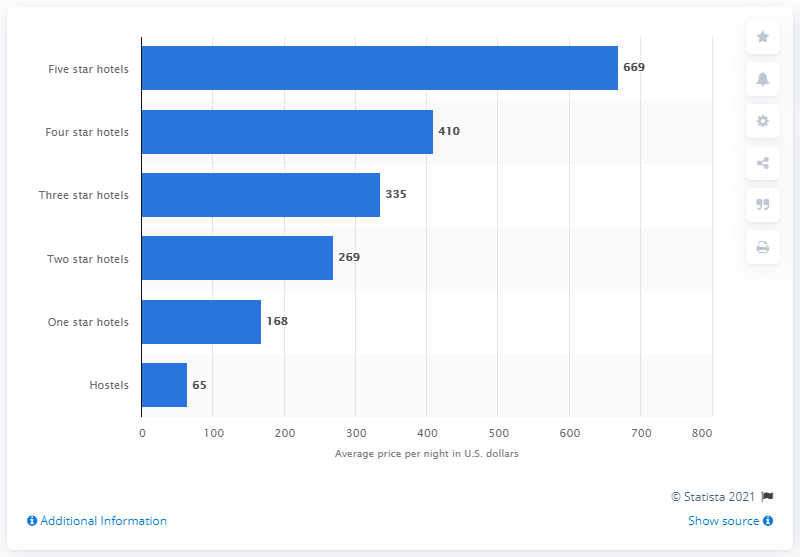Point out several critical features in this image. The difference between the first and second lowest bar value in the blue bar is 103. The difference between the shortest and tallest blue bars is -604. The cost of a five-star hotel per night is 669. 